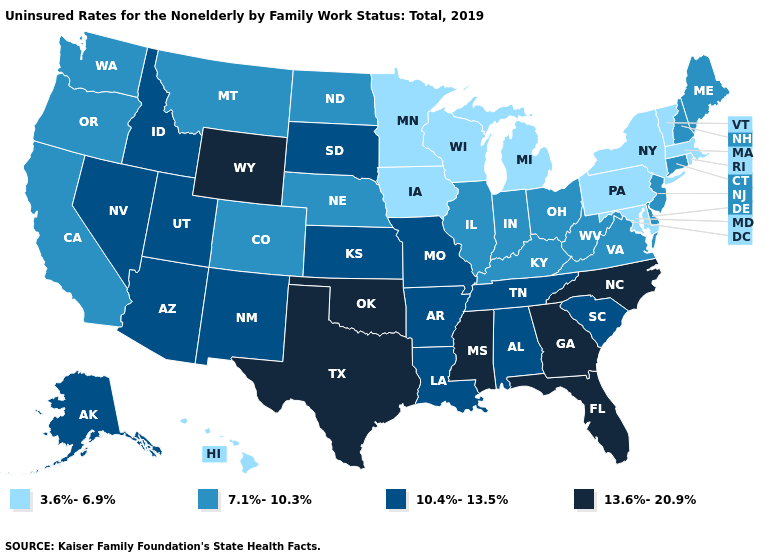How many symbols are there in the legend?
Write a very short answer. 4. Name the states that have a value in the range 13.6%-20.9%?
Give a very brief answer. Florida, Georgia, Mississippi, North Carolina, Oklahoma, Texas, Wyoming. Name the states that have a value in the range 7.1%-10.3%?
Keep it brief. California, Colorado, Connecticut, Delaware, Illinois, Indiana, Kentucky, Maine, Montana, Nebraska, New Hampshire, New Jersey, North Dakota, Ohio, Oregon, Virginia, Washington, West Virginia. What is the highest value in the MidWest ?
Keep it brief. 10.4%-13.5%. Which states have the highest value in the USA?
Quick response, please. Florida, Georgia, Mississippi, North Carolina, Oklahoma, Texas, Wyoming. Name the states that have a value in the range 13.6%-20.9%?
Be succinct. Florida, Georgia, Mississippi, North Carolina, Oklahoma, Texas, Wyoming. Name the states that have a value in the range 13.6%-20.9%?
Give a very brief answer. Florida, Georgia, Mississippi, North Carolina, Oklahoma, Texas, Wyoming. What is the value of Idaho?
Write a very short answer. 10.4%-13.5%. Does New York have a lower value than Oregon?
Quick response, please. Yes. Does Virginia have the lowest value in the South?
Be succinct. No. Does Alaska have a lower value than West Virginia?
Concise answer only. No. Does Arkansas have the lowest value in the South?
Write a very short answer. No. Name the states that have a value in the range 3.6%-6.9%?
Quick response, please. Hawaii, Iowa, Maryland, Massachusetts, Michigan, Minnesota, New York, Pennsylvania, Rhode Island, Vermont, Wisconsin. Which states have the lowest value in the MidWest?
Keep it brief. Iowa, Michigan, Minnesota, Wisconsin. What is the value of Maine?
Be succinct. 7.1%-10.3%. 